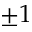Convert formula to latex. <formula><loc_0><loc_0><loc_500><loc_500>\pm 1</formula> 